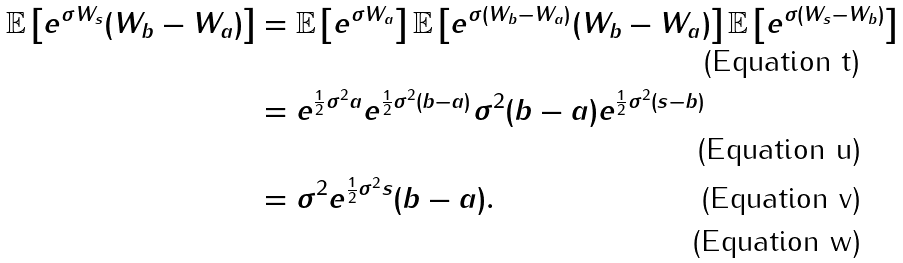Convert formula to latex. <formula><loc_0><loc_0><loc_500><loc_500>\mathbb { E } \left [ e ^ { \sigma W _ { s } } ( W _ { b } - W _ { a } ) \right ] & = \mathbb { E } \left [ e ^ { \sigma W _ { a } } \right ] \mathbb { E } \left [ e ^ { \sigma ( W _ { b } - W _ { a } ) } ( W _ { b } - W _ { a } ) \right ] \mathbb { E } \left [ e ^ { \sigma ( W _ { s } - W _ { b } ) } \right ] \\ & = e ^ { \frac { 1 } { 2 } \sigma ^ { 2 } a } e ^ { \frac { 1 } { 2 } \sigma ^ { 2 } ( b - a ) } \sigma ^ { 2 } ( b - a ) e ^ { \frac { 1 } { 2 } \sigma ^ { 2 } ( s - b ) } \\ & = \sigma ^ { 2 } e ^ { \frac { 1 } { 2 } \sigma ^ { 2 } s } ( b - a ) . \\</formula> 